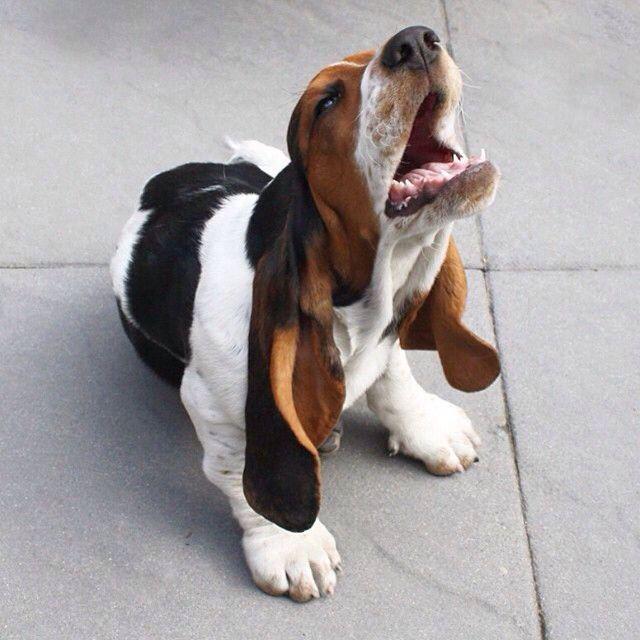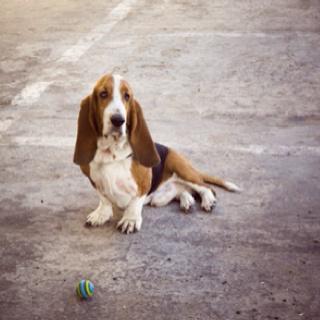The first image is the image on the left, the second image is the image on the right. Examine the images to the left and right. Is the description "An image shows one basset hound, which is looking up and toward the right." accurate? Answer yes or no. Yes. The first image is the image on the left, the second image is the image on the right. Given the left and right images, does the statement "One basset hound is looking up with its nose pointed into the air." hold true? Answer yes or no. Yes. 